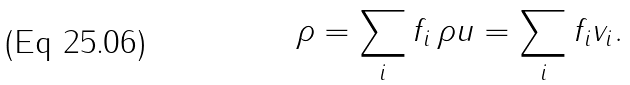Convert formula to latex. <formula><loc_0><loc_0><loc_500><loc_500>\rho = \sum _ { i } f _ { i } \, \rho { u } = \sum _ { i } f _ { i } { v } _ { i } .</formula> 